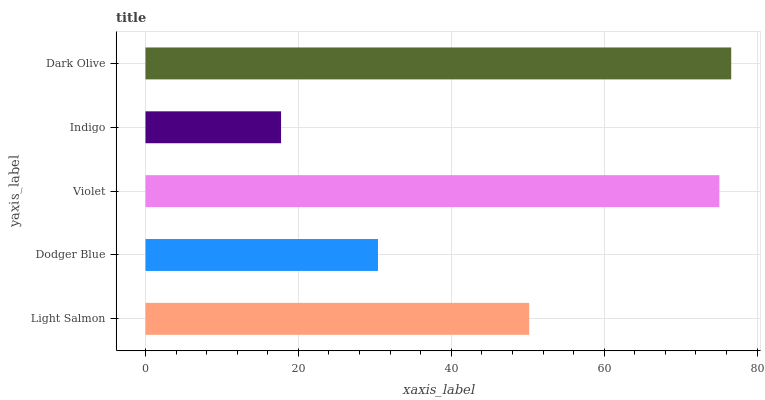Is Indigo the minimum?
Answer yes or no. Yes. Is Dark Olive the maximum?
Answer yes or no. Yes. Is Dodger Blue the minimum?
Answer yes or no. No. Is Dodger Blue the maximum?
Answer yes or no. No. Is Light Salmon greater than Dodger Blue?
Answer yes or no. Yes. Is Dodger Blue less than Light Salmon?
Answer yes or no. Yes. Is Dodger Blue greater than Light Salmon?
Answer yes or no. No. Is Light Salmon less than Dodger Blue?
Answer yes or no. No. Is Light Salmon the high median?
Answer yes or no. Yes. Is Light Salmon the low median?
Answer yes or no. Yes. Is Violet the high median?
Answer yes or no. No. Is Indigo the low median?
Answer yes or no. No. 